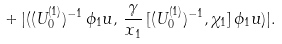<formula> <loc_0><loc_0><loc_500><loc_500>+ \, | ( ( U _ { 0 } ^ { ( 1 ) } ) ^ { - 1 } \, \phi _ { 1 } u , \, \frac { \gamma } { x _ { 1 } } \, [ ( U _ { 0 } ^ { ( 1 ) } ) ^ { - 1 } , \chi _ { 1 } ] \, \phi _ { 1 } u ) | .</formula> 